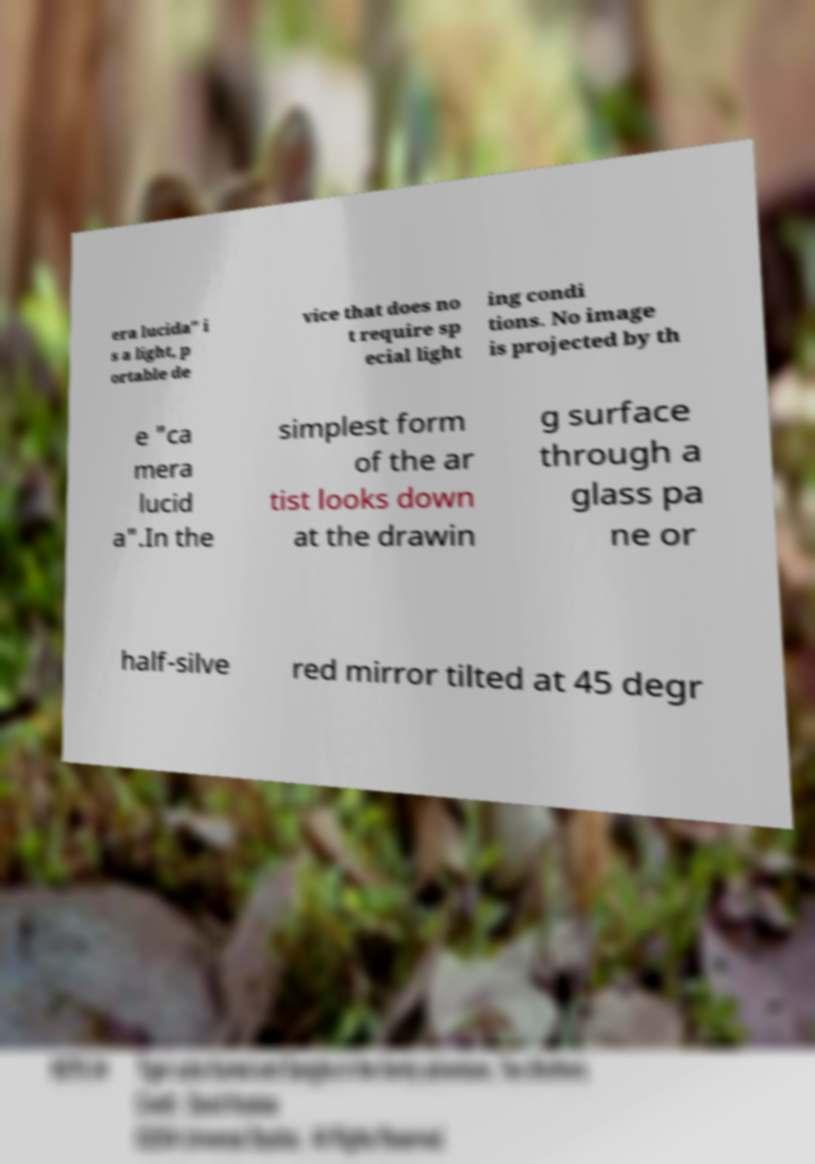Can you accurately transcribe the text from the provided image for me? era lucida" i s a light, p ortable de vice that does no t require sp ecial light ing condi tions. No image is projected by th e "ca mera lucid a".In the simplest form of the ar tist looks down at the drawin g surface through a glass pa ne or half-silve red mirror tilted at 45 degr 